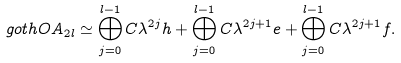<formula> <loc_0><loc_0><loc_500><loc_500>\ g o t h { O A } _ { 2 l } \simeq \bigoplus _ { j = 0 } ^ { l - 1 } { C } \lambda ^ { 2 j } h + \bigoplus _ { j = 0 } ^ { l - 1 } { C } \lambda ^ { 2 j + 1 } e + \bigoplus _ { j = 0 } ^ { l - 1 } { C } \lambda ^ { 2 j + 1 } f .</formula> 